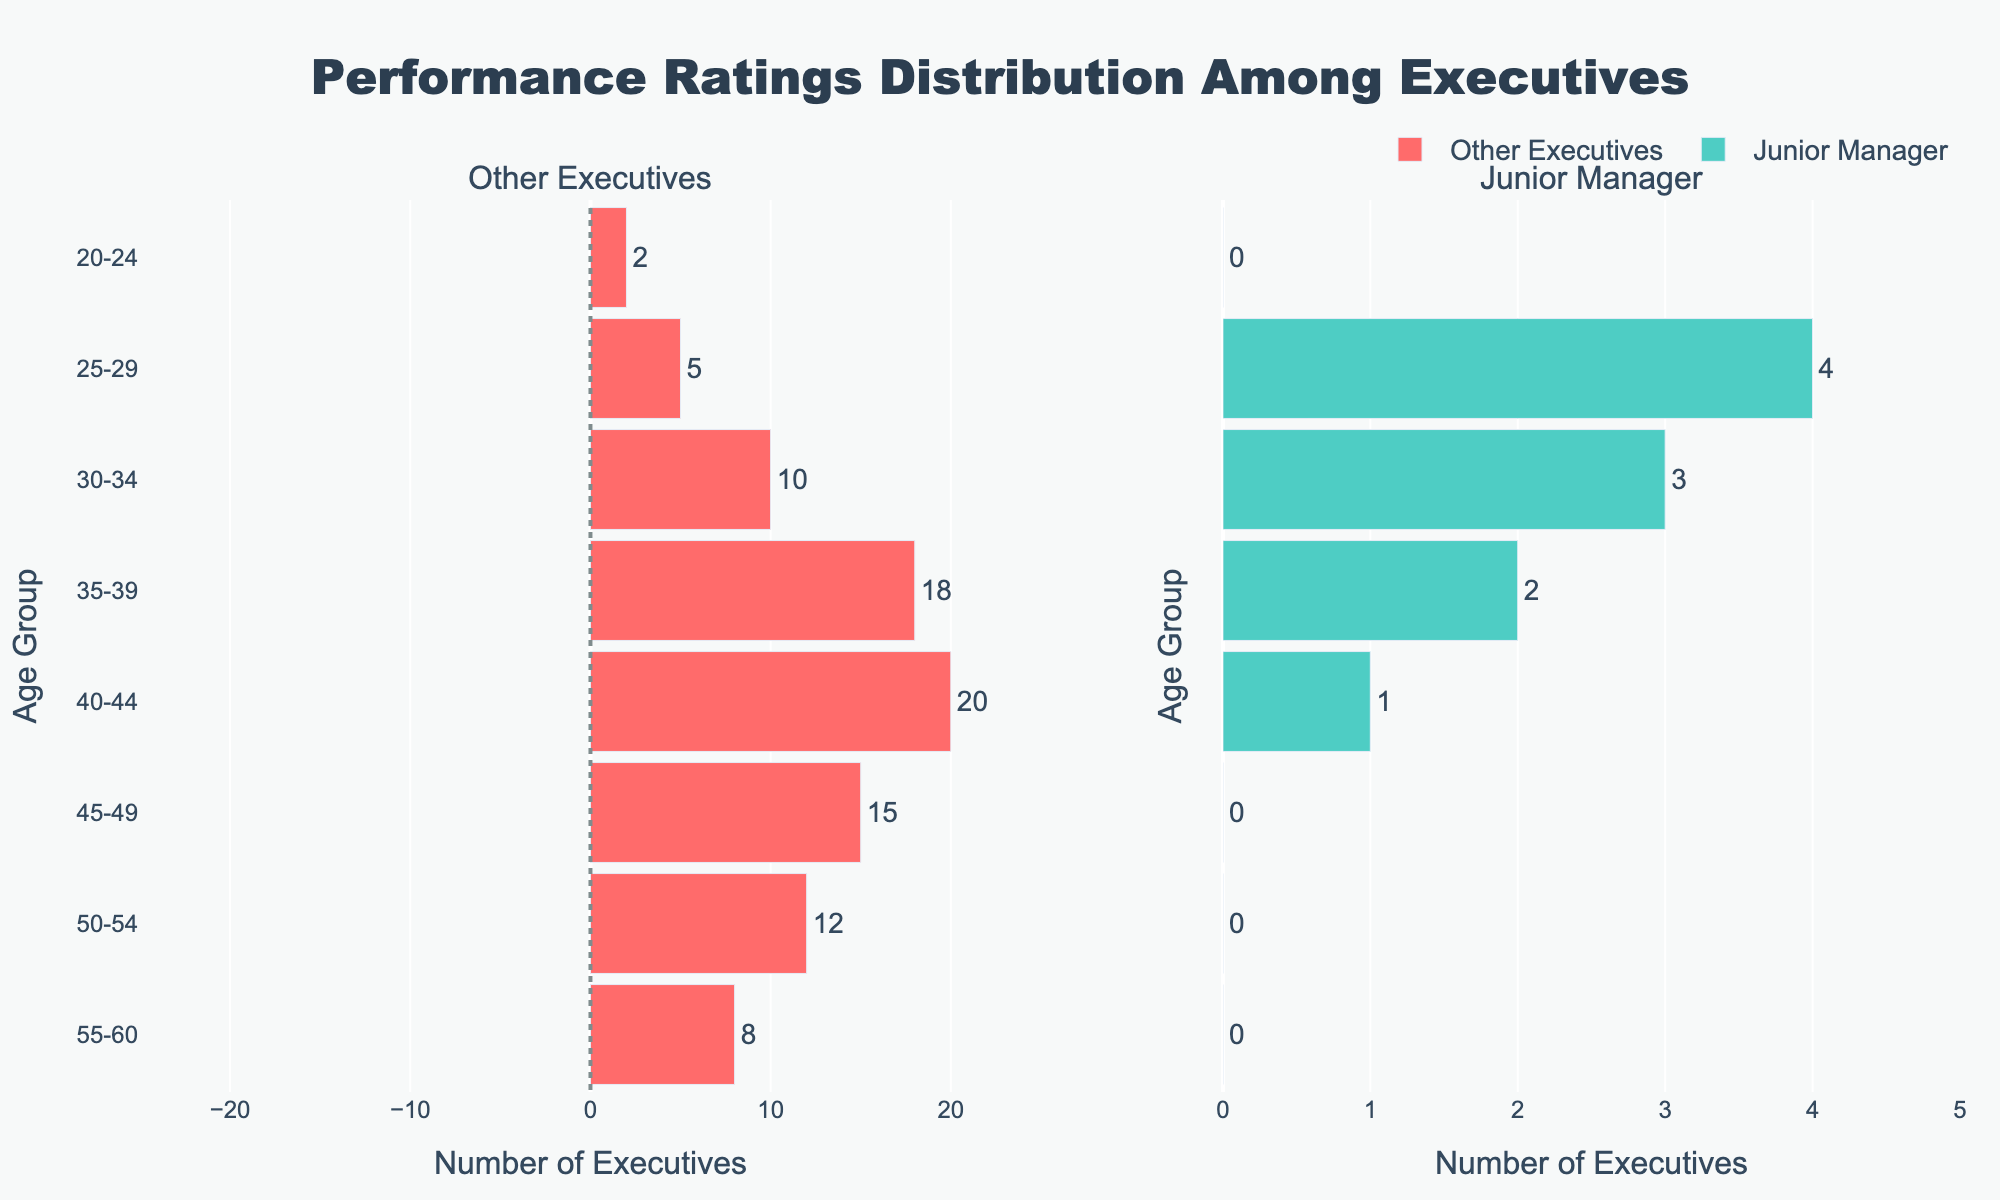What is the title of the figure? The title is prominently displayed at the top center of the plot. It reads "Performance Ratings Distribution Among Executives."
Answer: Performance Ratings Distribution Among Executives How many age groups are represented in the data? The vertical axis lists the different age groups. By counting them, we see there are 8 groups ranging from "20-24" to "55-60."
Answer: 8 In which age group does the Junior Manager have the highest score? Look at the right side of the graph under "Junior Manager." The bar for the age group "25-29" is the longest, indicating the highest score.
Answer: 25-29 Which age group of Other Executives shows the lowest performance? Look at the left side of the graph under "Other Executives." The bar for the age group "40-44" extends the farthest to the left, indicating the lowest performance.
Answer: 40-44 Compare the performance of the Junior Manager in the "35-39" age group with Other Executives in the same group. On the right side, the bar for "35-39" under "Junior Manager" extends to 2, while on the left side, the bar for the same age group under "Other Executives" extends to -18.
Answer: Junior Manager: 2, Other Executives: -18 Compare the number of executives in the age group "50-54" between Other Executives and the Junior Manager. Look at the lengths of the bars for the age group "50-54." For Other Executives, the bar extends to -12, and the Junior Manager has a score of 0 for this age group.
Answer: 12 Executives for Other Executives, 0 for Junior Manager What is the range of performance scores represented for the Junior Manager? On the right side, the shortest bar extends to 0 and the longest bar extends to 4. So the range is 0 to 4.
Answer: 0 to 4 Estimate the overall performance trend for the Junior Manager as the age increases. Looking at the "Junior Manager" side, performance tends to increase steadily from "20-24" to "30-34," peaking at "25-29" and "30-34," then drops to 1 at "40-44."
Answer: Increasing till age 30-34, then slightly lower 